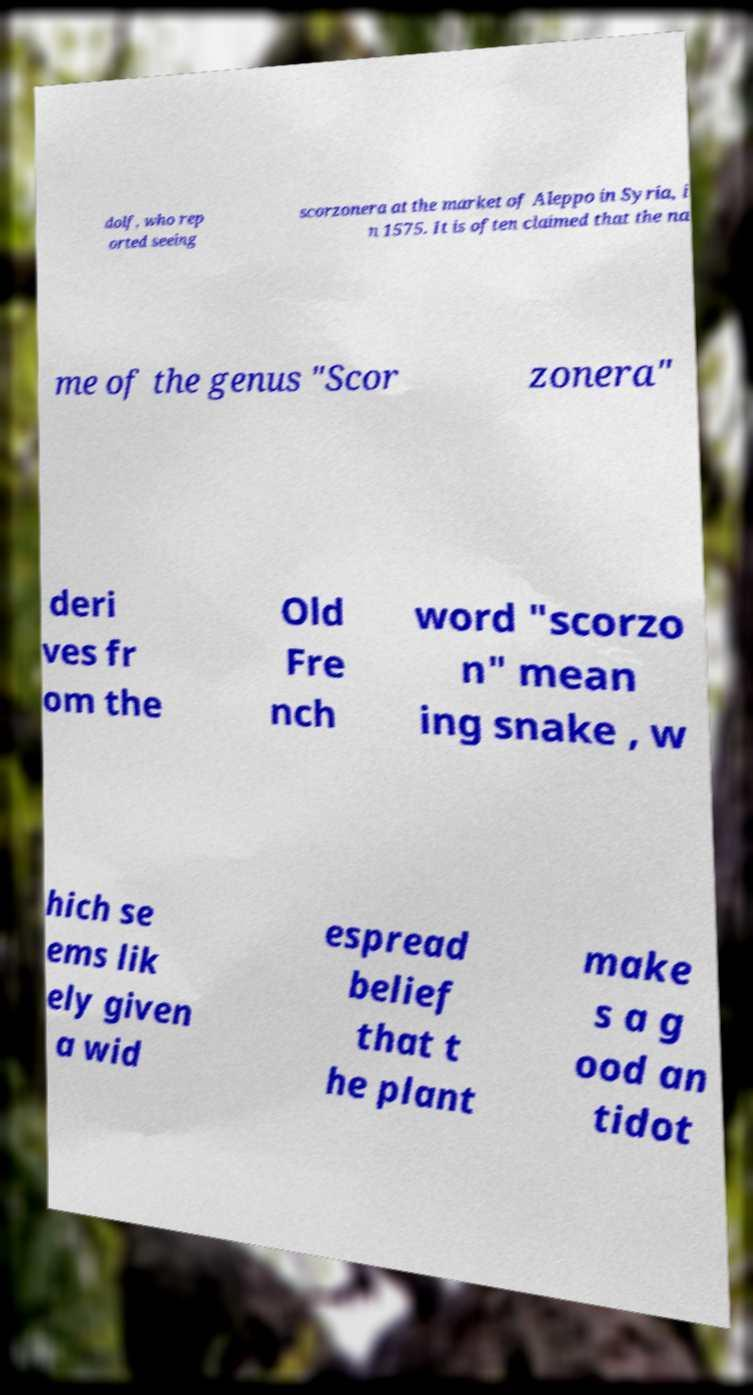Please identify and transcribe the text found in this image. dolf, who rep orted seeing scorzonera at the market of Aleppo in Syria, i n 1575. It is often claimed that the na me of the genus "Scor zonera" deri ves fr om the Old Fre nch word "scorzo n" mean ing snake , w hich se ems lik ely given a wid espread belief that t he plant make s a g ood an tidot 